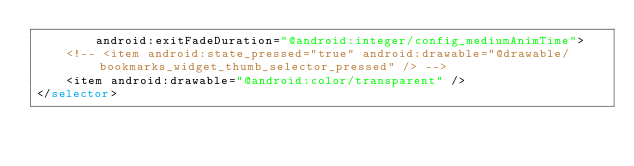<code> <loc_0><loc_0><loc_500><loc_500><_XML_>        android:exitFadeDuration="@android:integer/config_mediumAnimTime">
    <!-- <item android:state_pressed="true" android:drawable="@drawable/bookmarks_widget_thumb_selector_pressed" /> -->
    <item android:drawable="@android:color/transparent" />
</selector>

</code> 